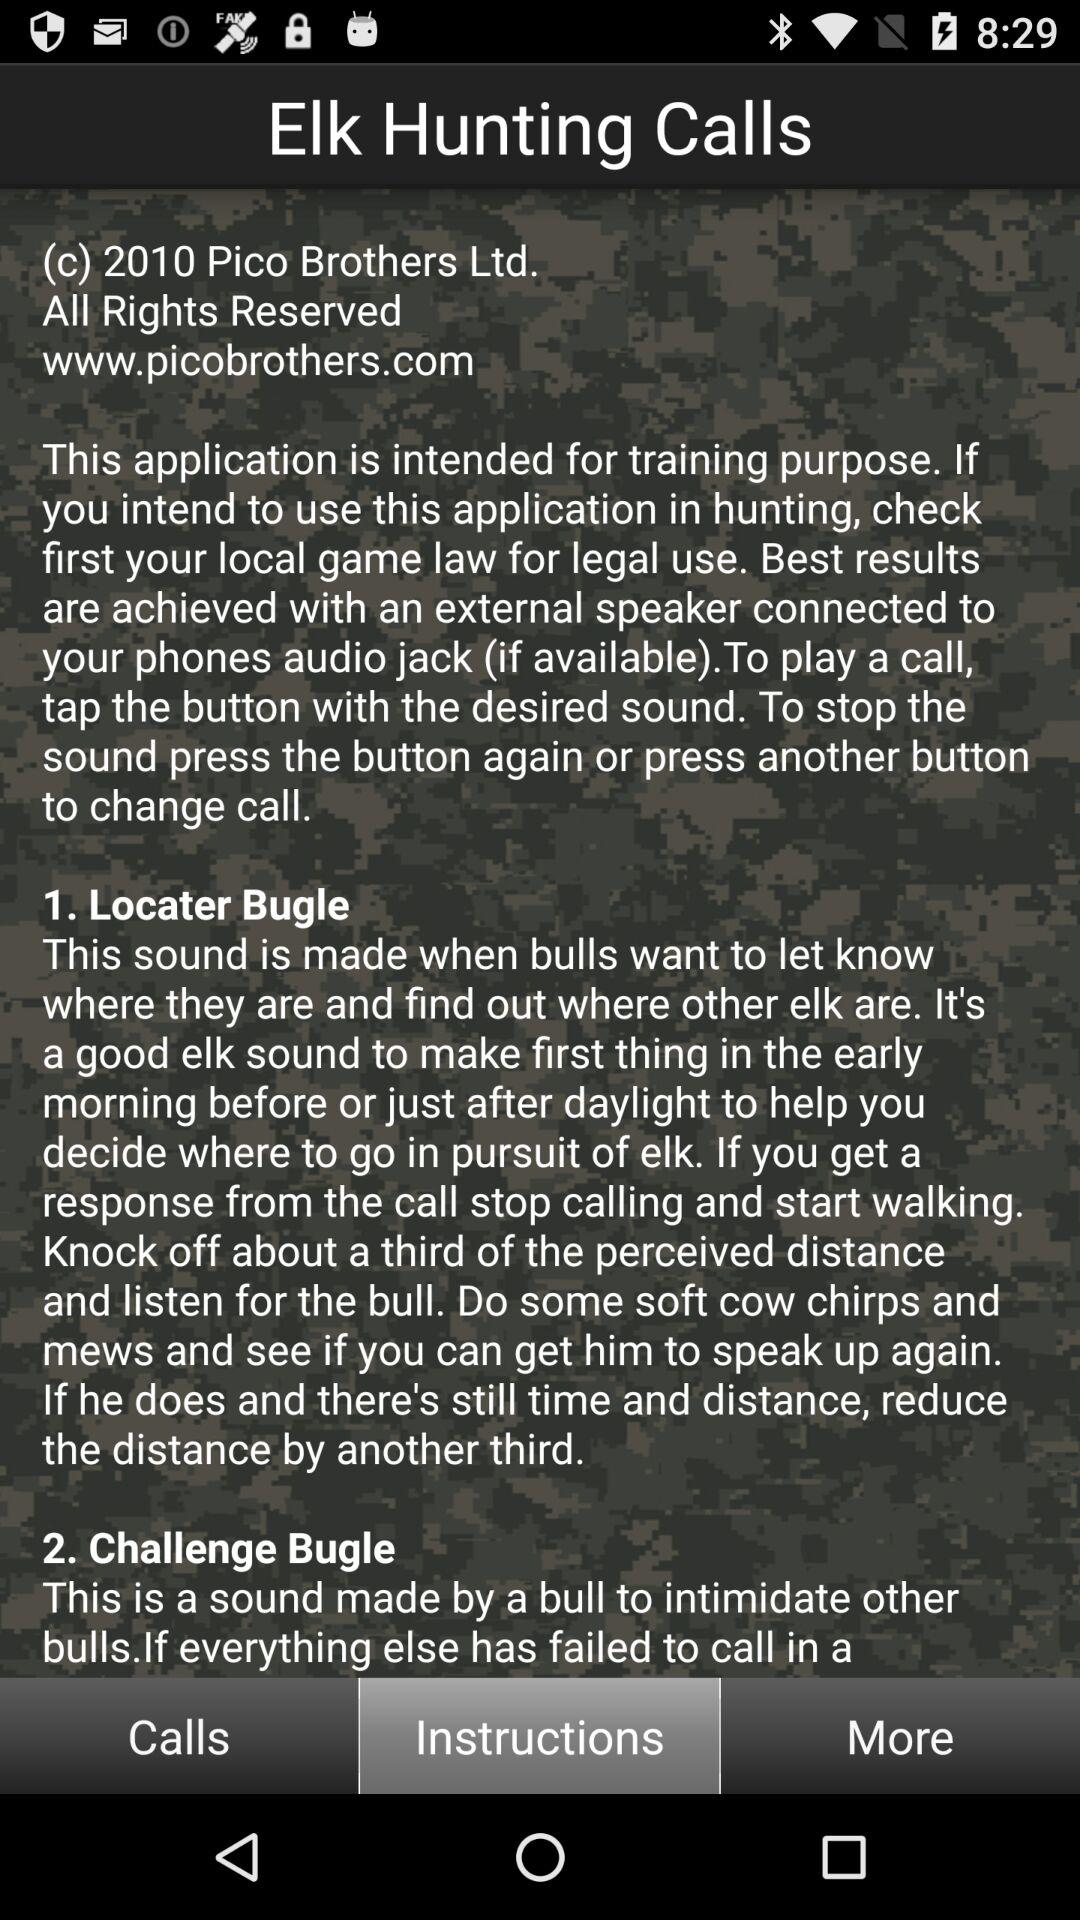How many bull bugle sounds are there?
Answer the question using a single word or phrase. 2 